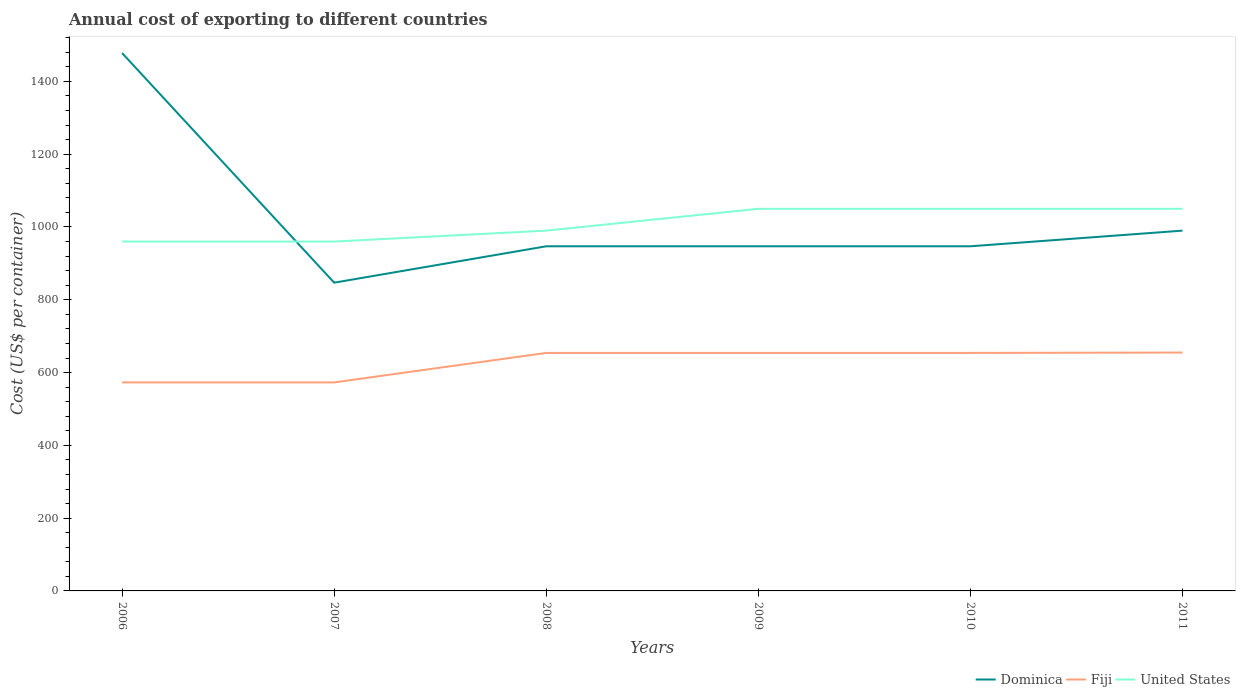How many different coloured lines are there?
Offer a very short reply. 3. Is the number of lines equal to the number of legend labels?
Your response must be concise. Yes. Across all years, what is the maximum total annual cost of exporting in United States?
Offer a very short reply. 960. In which year was the total annual cost of exporting in Fiji maximum?
Offer a terse response. 2006. What is the total total annual cost of exporting in Fiji in the graph?
Keep it short and to the point. -81. What is the difference between the highest and the second highest total annual cost of exporting in United States?
Ensure brevity in your answer.  90. Is the total annual cost of exporting in United States strictly greater than the total annual cost of exporting in Fiji over the years?
Your response must be concise. No. How many years are there in the graph?
Offer a terse response. 6. Are the values on the major ticks of Y-axis written in scientific E-notation?
Provide a succinct answer. No. Does the graph contain grids?
Your response must be concise. No. What is the title of the graph?
Your answer should be very brief. Annual cost of exporting to different countries. Does "Algeria" appear as one of the legend labels in the graph?
Offer a terse response. No. What is the label or title of the X-axis?
Offer a very short reply. Years. What is the label or title of the Y-axis?
Provide a short and direct response. Cost (US$ per container). What is the Cost (US$ per container) of Dominica in 2006?
Your answer should be compact. 1478. What is the Cost (US$ per container) of Fiji in 2006?
Your answer should be compact. 573. What is the Cost (US$ per container) in United States in 2006?
Provide a succinct answer. 960. What is the Cost (US$ per container) of Dominica in 2007?
Offer a very short reply. 847. What is the Cost (US$ per container) of Fiji in 2007?
Your response must be concise. 573. What is the Cost (US$ per container) of United States in 2007?
Provide a succinct answer. 960. What is the Cost (US$ per container) in Dominica in 2008?
Keep it short and to the point. 947. What is the Cost (US$ per container) in Fiji in 2008?
Give a very brief answer. 654. What is the Cost (US$ per container) of United States in 2008?
Provide a succinct answer. 990. What is the Cost (US$ per container) of Dominica in 2009?
Offer a very short reply. 947. What is the Cost (US$ per container) of Fiji in 2009?
Your response must be concise. 654. What is the Cost (US$ per container) of United States in 2009?
Ensure brevity in your answer.  1050. What is the Cost (US$ per container) in Dominica in 2010?
Offer a very short reply. 947. What is the Cost (US$ per container) in Fiji in 2010?
Provide a succinct answer. 654. What is the Cost (US$ per container) of United States in 2010?
Keep it short and to the point. 1050. What is the Cost (US$ per container) in Dominica in 2011?
Your answer should be very brief. 990. What is the Cost (US$ per container) of Fiji in 2011?
Offer a terse response. 655. What is the Cost (US$ per container) in United States in 2011?
Provide a short and direct response. 1050. Across all years, what is the maximum Cost (US$ per container) in Dominica?
Offer a very short reply. 1478. Across all years, what is the maximum Cost (US$ per container) of Fiji?
Provide a short and direct response. 655. Across all years, what is the maximum Cost (US$ per container) in United States?
Offer a very short reply. 1050. Across all years, what is the minimum Cost (US$ per container) in Dominica?
Make the answer very short. 847. Across all years, what is the minimum Cost (US$ per container) of Fiji?
Keep it short and to the point. 573. Across all years, what is the minimum Cost (US$ per container) of United States?
Your response must be concise. 960. What is the total Cost (US$ per container) of Dominica in the graph?
Provide a short and direct response. 6156. What is the total Cost (US$ per container) of Fiji in the graph?
Make the answer very short. 3763. What is the total Cost (US$ per container) in United States in the graph?
Provide a succinct answer. 6060. What is the difference between the Cost (US$ per container) in Dominica in 2006 and that in 2007?
Keep it short and to the point. 631. What is the difference between the Cost (US$ per container) in Dominica in 2006 and that in 2008?
Keep it short and to the point. 531. What is the difference between the Cost (US$ per container) in Fiji in 2006 and that in 2008?
Keep it short and to the point. -81. What is the difference between the Cost (US$ per container) of Dominica in 2006 and that in 2009?
Keep it short and to the point. 531. What is the difference between the Cost (US$ per container) in Fiji in 2006 and that in 2009?
Your answer should be compact. -81. What is the difference between the Cost (US$ per container) of United States in 2006 and that in 2009?
Make the answer very short. -90. What is the difference between the Cost (US$ per container) in Dominica in 2006 and that in 2010?
Offer a terse response. 531. What is the difference between the Cost (US$ per container) in Fiji in 2006 and that in 2010?
Offer a terse response. -81. What is the difference between the Cost (US$ per container) of United States in 2006 and that in 2010?
Make the answer very short. -90. What is the difference between the Cost (US$ per container) of Dominica in 2006 and that in 2011?
Offer a terse response. 488. What is the difference between the Cost (US$ per container) in Fiji in 2006 and that in 2011?
Offer a very short reply. -82. What is the difference between the Cost (US$ per container) in United States in 2006 and that in 2011?
Offer a very short reply. -90. What is the difference between the Cost (US$ per container) of Dominica in 2007 and that in 2008?
Provide a succinct answer. -100. What is the difference between the Cost (US$ per container) of Fiji in 2007 and that in 2008?
Provide a succinct answer. -81. What is the difference between the Cost (US$ per container) of United States in 2007 and that in 2008?
Offer a very short reply. -30. What is the difference between the Cost (US$ per container) of Dominica in 2007 and that in 2009?
Your response must be concise. -100. What is the difference between the Cost (US$ per container) in Fiji in 2007 and that in 2009?
Provide a succinct answer. -81. What is the difference between the Cost (US$ per container) of United States in 2007 and that in 2009?
Provide a succinct answer. -90. What is the difference between the Cost (US$ per container) in Dominica in 2007 and that in 2010?
Give a very brief answer. -100. What is the difference between the Cost (US$ per container) of Fiji in 2007 and that in 2010?
Your response must be concise. -81. What is the difference between the Cost (US$ per container) of United States in 2007 and that in 2010?
Provide a succinct answer. -90. What is the difference between the Cost (US$ per container) in Dominica in 2007 and that in 2011?
Your answer should be compact. -143. What is the difference between the Cost (US$ per container) in Fiji in 2007 and that in 2011?
Provide a short and direct response. -82. What is the difference between the Cost (US$ per container) of United States in 2007 and that in 2011?
Provide a short and direct response. -90. What is the difference between the Cost (US$ per container) in Dominica in 2008 and that in 2009?
Your answer should be very brief. 0. What is the difference between the Cost (US$ per container) in United States in 2008 and that in 2009?
Provide a succinct answer. -60. What is the difference between the Cost (US$ per container) of Fiji in 2008 and that in 2010?
Offer a very short reply. 0. What is the difference between the Cost (US$ per container) in United States in 2008 and that in 2010?
Give a very brief answer. -60. What is the difference between the Cost (US$ per container) of Dominica in 2008 and that in 2011?
Provide a short and direct response. -43. What is the difference between the Cost (US$ per container) in Fiji in 2008 and that in 2011?
Offer a very short reply. -1. What is the difference between the Cost (US$ per container) in United States in 2008 and that in 2011?
Provide a short and direct response. -60. What is the difference between the Cost (US$ per container) of Fiji in 2009 and that in 2010?
Your response must be concise. 0. What is the difference between the Cost (US$ per container) in United States in 2009 and that in 2010?
Ensure brevity in your answer.  0. What is the difference between the Cost (US$ per container) in Dominica in 2009 and that in 2011?
Give a very brief answer. -43. What is the difference between the Cost (US$ per container) in Fiji in 2009 and that in 2011?
Provide a succinct answer. -1. What is the difference between the Cost (US$ per container) of Dominica in 2010 and that in 2011?
Provide a short and direct response. -43. What is the difference between the Cost (US$ per container) of Fiji in 2010 and that in 2011?
Provide a short and direct response. -1. What is the difference between the Cost (US$ per container) of United States in 2010 and that in 2011?
Offer a very short reply. 0. What is the difference between the Cost (US$ per container) in Dominica in 2006 and the Cost (US$ per container) in Fiji in 2007?
Provide a short and direct response. 905. What is the difference between the Cost (US$ per container) of Dominica in 2006 and the Cost (US$ per container) of United States in 2007?
Your answer should be very brief. 518. What is the difference between the Cost (US$ per container) in Fiji in 2006 and the Cost (US$ per container) in United States in 2007?
Provide a succinct answer. -387. What is the difference between the Cost (US$ per container) in Dominica in 2006 and the Cost (US$ per container) in Fiji in 2008?
Keep it short and to the point. 824. What is the difference between the Cost (US$ per container) in Dominica in 2006 and the Cost (US$ per container) in United States in 2008?
Make the answer very short. 488. What is the difference between the Cost (US$ per container) in Fiji in 2006 and the Cost (US$ per container) in United States in 2008?
Offer a very short reply. -417. What is the difference between the Cost (US$ per container) in Dominica in 2006 and the Cost (US$ per container) in Fiji in 2009?
Offer a very short reply. 824. What is the difference between the Cost (US$ per container) of Dominica in 2006 and the Cost (US$ per container) of United States in 2009?
Make the answer very short. 428. What is the difference between the Cost (US$ per container) of Fiji in 2006 and the Cost (US$ per container) of United States in 2009?
Offer a terse response. -477. What is the difference between the Cost (US$ per container) in Dominica in 2006 and the Cost (US$ per container) in Fiji in 2010?
Give a very brief answer. 824. What is the difference between the Cost (US$ per container) in Dominica in 2006 and the Cost (US$ per container) in United States in 2010?
Offer a terse response. 428. What is the difference between the Cost (US$ per container) of Fiji in 2006 and the Cost (US$ per container) of United States in 2010?
Ensure brevity in your answer.  -477. What is the difference between the Cost (US$ per container) of Dominica in 2006 and the Cost (US$ per container) of Fiji in 2011?
Make the answer very short. 823. What is the difference between the Cost (US$ per container) of Dominica in 2006 and the Cost (US$ per container) of United States in 2011?
Keep it short and to the point. 428. What is the difference between the Cost (US$ per container) of Fiji in 2006 and the Cost (US$ per container) of United States in 2011?
Provide a succinct answer. -477. What is the difference between the Cost (US$ per container) of Dominica in 2007 and the Cost (US$ per container) of Fiji in 2008?
Provide a succinct answer. 193. What is the difference between the Cost (US$ per container) of Dominica in 2007 and the Cost (US$ per container) of United States in 2008?
Offer a terse response. -143. What is the difference between the Cost (US$ per container) in Fiji in 2007 and the Cost (US$ per container) in United States in 2008?
Your answer should be very brief. -417. What is the difference between the Cost (US$ per container) in Dominica in 2007 and the Cost (US$ per container) in Fiji in 2009?
Make the answer very short. 193. What is the difference between the Cost (US$ per container) in Dominica in 2007 and the Cost (US$ per container) in United States in 2009?
Make the answer very short. -203. What is the difference between the Cost (US$ per container) in Fiji in 2007 and the Cost (US$ per container) in United States in 2009?
Keep it short and to the point. -477. What is the difference between the Cost (US$ per container) in Dominica in 2007 and the Cost (US$ per container) in Fiji in 2010?
Keep it short and to the point. 193. What is the difference between the Cost (US$ per container) of Dominica in 2007 and the Cost (US$ per container) of United States in 2010?
Your response must be concise. -203. What is the difference between the Cost (US$ per container) in Fiji in 2007 and the Cost (US$ per container) in United States in 2010?
Your answer should be compact. -477. What is the difference between the Cost (US$ per container) of Dominica in 2007 and the Cost (US$ per container) of Fiji in 2011?
Keep it short and to the point. 192. What is the difference between the Cost (US$ per container) of Dominica in 2007 and the Cost (US$ per container) of United States in 2011?
Your response must be concise. -203. What is the difference between the Cost (US$ per container) of Fiji in 2007 and the Cost (US$ per container) of United States in 2011?
Ensure brevity in your answer.  -477. What is the difference between the Cost (US$ per container) of Dominica in 2008 and the Cost (US$ per container) of Fiji in 2009?
Keep it short and to the point. 293. What is the difference between the Cost (US$ per container) in Dominica in 2008 and the Cost (US$ per container) in United States in 2009?
Offer a very short reply. -103. What is the difference between the Cost (US$ per container) in Fiji in 2008 and the Cost (US$ per container) in United States in 2009?
Keep it short and to the point. -396. What is the difference between the Cost (US$ per container) of Dominica in 2008 and the Cost (US$ per container) of Fiji in 2010?
Ensure brevity in your answer.  293. What is the difference between the Cost (US$ per container) in Dominica in 2008 and the Cost (US$ per container) in United States in 2010?
Your answer should be compact. -103. What is the difference between the Cost (US$ per container) in Fiji in 2008 and the Cost (US$ per container) in United States in 2010?
Provide a succinct answer. -396. What is the difference between the Cost (US$ per container) in Dominica in 2008 and the Cost (US$ per container) in Fiji in 2011?
Make the answer very short. 292. What is the difference between the Cost (US$ per container) of Dominica in 2008 and the Cost (US$ per container) of United States in 2011?
Provide a succinct answer. -103. What is the difference between the Cost (US$ per container) of Fiji in 2008 and the Cost (US$ per container) of United States in 2011?
Offer a terse response. -396. What is the difference between the Cost (US$ per container) of Dominica in 2009 and the Cost (US$ per container) of Fiji in 2010?
Offer a terse response. 293. What is the difference between the Cost (US$ per container) of Dominica in 2009 and the Cost (US$ per container) of United States in 2010?
Ensure brevity in your answer.  -103. What is the difference between the Cost (US$ per container) in Fiji in 2009 and the Cost (US$ per container) in United States in 2010?
Provide a succinct answer. -396. What is the difference between the Cost (US$ per container) of Dominica in 2009 and the Cost (US$ per container) of Fiji in 2011?
Your answer should be very brief. 292. What is the difference between the Cost (US$ per container) of Dominica in 2009 and the Cost (US$ per container) of United States in 2011?
Ensure brevity in your answer.  -103. What is the difference between the Cost (US$ per container) in Fiji in 2009 and the Cost (US$ per container) in United States in 2011?
Make the answer very short. -396. What is the difference between the Cost (US$ per container) in Dominica in 2010 and the Cost (US$ per container) in Fiji in 2011?
Offer a terse response. 292. What is the difference between the Cost (US$ per container) in Dominica in 2010 and the Cost (US$ per container) in United States in 2011?
Offer a terse response. -103. What is the difference between the Cost (US$ per container) in Fiji in 2010 and the Cost (US$ per container) in United States in 2011?
Offer a very short reply. -396. What is the average Cost (US$ per container) of Dominica per year?
Offer a very short reply. 1026. What is the average Cost (US$ per container) in Fiji per year?
Make the answer very short. 627.17. What is the average Cost (US$ per container) of United States per year?
Your answer should be compact. 1010. In the year 2006, what is the difference between the Cost (US$ per container) in Dominica and Cost (US$ per container) in Fiji?
Give a very brief answer. 905. In the year 2006, what is the difference between the Cost (US$ per container) of Dominica and Cost (US$ per container) of United States?
Provide a succinct answer. 518. In the year 2006, what is the difference between the Cost (US$ per container) in Fiji and Cost (US$ per container) in United States?
Your answer should be very brief. -387. In the year 2007, what is the difference between the Cost (US$ per container) of Dominica and Cost (US$ per container) of Fiji?
Provide a succinct answer. 274. In the year 2007, what is the difference between the Cost (US$ per container) in Dominica and Cost (US$ per container) in United States?
Your answer should be compact. -113. In the year 2007, what is the difference between the Cost (US$ per container) of Fiji and Cost (US$ per container) of United States?
Give a very brief answer. -387. In the year 2008, what is the difference between the Cost (US$ per container) in Dominica and Cost (US$ per container) in Fiji?
Your response must be concise. 293. In the year 2008, what is the difference between the Cost (US$ per container) in Dominica and Cost (US$ per container) in United States?
Offer a very short reply. -43. In the year 2008, what is the difference between the Cost (US$ per container) in Fiji and Cost (US$ per container) in United States?
Keep it short and to the point. -336. In the year 2009, what is the difference between the Cost (US$ per container) in Dominica and Cost (US$ per container) in Fiji?
Make the answer very short. 293. In the year 2009, what is the difference between the Cost (US$ per container) in Dominica and Cost (US$ per container) in United States?
Provide a succinct answer. -103. In the year 2009, what is the difference between the Cost (US$ per container) of Fiji and Cost (US$ per container) of United States?
Give a very brief answer. -396. In the year 2010, what is the difference between the Cost (US$ per container) in Dominica and Cost (US$ per container) in Fiji?
Your response must be concise. 293. In the year 2010, what is the difference between the Cost (US$ per container) of Dominica and Cost (US$ per container) of United States?
Provide a succinct answer. -103. In the year 2010, what is the difference between the Cost (US$ per container) in Fiji and Cost (US$ per container) in United States?
Your response must be concise. -396. In the year 2011, what is the difference between the Cost (US$ per container) in Dominica and Cost (US$ per container) in Fiji?
Your answer should be compact. 335. In the year 2011, what is the difference between the Cost (US$ per container) of Dominica and Cost (US$ per container) of United States?
Make the answer very short. -60. In the year 2011, what is the difference between the Cost (US$ per container) of Fiji and Cost (US$ per container) of United States?
Your response must be concise. -395. What is the ratio of the Cost (US$ per container) in Dominica in 2006 to that in 2007?
Make the answer very short. 1.75. What is the ratio of the Cost (US$ per container) in Fiji in 2006 to that in 2007?
Your answer should be compact. 1. What is the ratio of the Cost (US$ per container) of Dominica in 2006 to that in 2008?
Your answer should be very brief. 1.56. What is the ratio of the Cost (US$ per container) of Fiji in 2006 to that in 2008?
Offer a terse response. 0.88. What is the ratio of the Cost (US$ per container) of United States in 2006 to that in 2008?
Your answer should be very brief. 0.97. What is the ratio of the Cost (US$ per container) in Dominica in 2006 to that in 2009?
Your response must be concise. 1.56. What is the ratio of the Cost (US$ per container) of Fiji in 2006 to that in 2009?
Your answer should be very brief. 0.88. What is the ratio of the Cost (US$ per container) in United States in 2006 to that in 2009?
Provide a short and direct response. 0.91. What is the ratio of the Cost (US$ per container) of Dominica in 2006 to that in 2010?
Make the answer very short. 1.56. What is the ratio of the Cost (US$ per container) of Fiji in 2006 to that in 2010?
Ensure brevity in your answer.  0.88. What is the ratio of the Cost (US$ per container) in United States in 2006 to that in 2010?
Give a very brief answer. 0.91. What is the ratio of the Cost (US$ per container) in Dominica in 2006 to that in 2011?
Make the answer very short. 1.49. What is the ratio of the Cost (US$ per container) of Fiji in 2006 to that in 2011?
Provide a short and direct response. 0.87. What is the ratio of the Cost (US$ per container) of United States in 2006 to that in 2011?
Keep it short and to the point. 0.91. What is the ratio of the Cost (US$ per container) of Dominica in 2007 to that in 2008?
Keep it short and to the point. 0.89. What is the ratio of the Cost (US$ per container) of Fiji in 2007 to that in 2008?
Provide a succinct answer. 0.88. What is the ratio of the Cost (US$ per container) in United States in 2007 to that in 2008?
Make the answer very short. 0.97. What is the ratio of the Cost (US$ per container) of Dominica in 2007 to that in 2009?
Your response must be concise. 0.89. What is the ratio of the Cost (US$ per container) in Fiji in 2007 to that in 2009?
Provide a succinct answer. 0.88. What is the ratio of the Cost (US$ per container) of United States in 2007 to that in 2009?
Your answer should be compact. 0.91. What is the ratio of the Cost (US$ per container) in Dominica in 2007 to that in 2010?
Provide a short and direct response. 0.89. What is the ratio of the Cost (US$ per container) in Fiji in 2007 to that in 2010?
Your response must be concise. 0.88. What is the ratio of the Cost (US$ per container) in United States in 2007 to that in 2010?
Provide a short and direct response. 0.91. What is the ratio of the Cost (US$ per container) in Dominica in 2007 to that in 2011?
Ensure brevity in your answer.  0.86. What is the ratio of the Cost (US$ per container) in Fiji in 2007 to that in 2011?
Your response must be concise. 0.87. What is the ratio of the Cost (US$ per container) in United States in 2007 to that in 2011?
Offer a very short reply. 0.91. What is the ratio of the Cost (US$ per container) of Dominica in 2008 to that in 2009?
Provide a short and direct response. 1. What is the ratio of the Cost (US$ per container) of United States in 2008 to that in 2009?
Offer a very short reply. 0.94. What is the ratio of the Cost (US$ per container) of Fiji in 2008 to that in 2010?
Your response must be concise. 1. What is the ratio of the Cost (US$ per container) of United States in 2008 to that in 2010?
Offer a terse response. 0.94. What is the ratio of the Cost (US$ per container) in Dominica in 2008 to that in 2011?
Make the answer very short. 0.96. What is the ratio of the Cost (US$ per container) in Fiji in 2008 to that in 2011?
Give a very brief answer. 1. What is the ratio of the Cost (US$ per container) of United States in 2008 to that in 2011?
Give a very brief answer. 0.94. What is the ratio of the Cost (US$ per container) of Dominica in 2009 to that in 2010?
Offer a very short reply. 1. What is the ratio of the Cost (US$ per container) of Fiji in 2009 to that in 2010?
Offer a very short reply. 1. What is the ratio of the Cost (US$ per container) of Dominica in 2009 to that in 2011?
Your response must be concise. 0.96. What is the ratio of the Cost (US$ per container) in Dominica in 2010 to that in 2011?
Offer a very short reply. 0.96. What is the ratio of the Cost (US$ per container) of Fiji in 2010 to that in 2011?
Provide a short and direct response. 1. What is the difference between the highest and the second highest Cost (US$ per container) in Dominica?
Your response must be concise. 488. What is the difference between the highest and the second highest Cost (US$ per container) of United States?
Your response must be concise. 0. What is the difference between the highest and the lowest Cost (US$ per container) in Dominica?
Provide a succinct answer. 631. What is the difference between the highest and the lowest Cost (US$ per container) in United States?
Your answer should be compact. 90. 